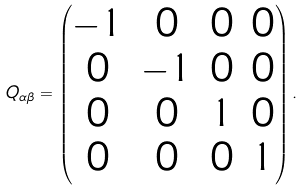Convert formula to latex. <formula><loc_0><loc_0><loc_500><loc_500>Q _ { \alpha \beta } = \left ( \begin{matrix} - 1 & 0 & 0 & 0 \\ 0 & - 1 & 0 & 0 \\ 0 & 0 & 1 & 0 \\ 0 & 0 & 0 & 1 \\ \end{matrix} \right ) .</formula> 